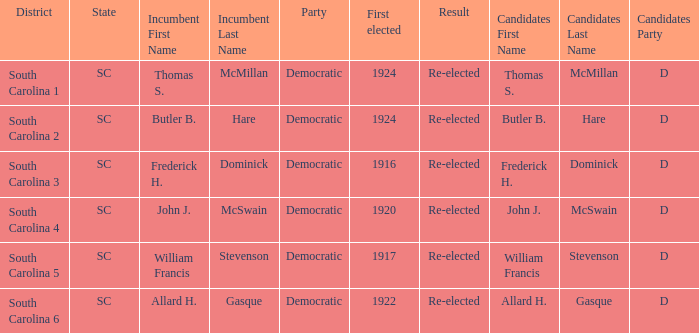What is the total number of results where the district is south carolina 5? 1.0. 